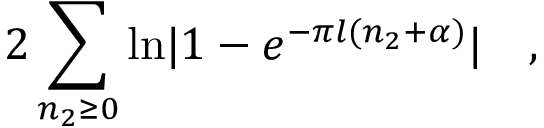Convert formula to latex. <formula><loc_0><loc_0><loc_500><loc_500>2 \sum _ { n _ { 2 } \geq 0 } \ln | 1 - e ^ { - \pi l ( n _ { 2 } + \alpha ) } | \quad ,</formula> 